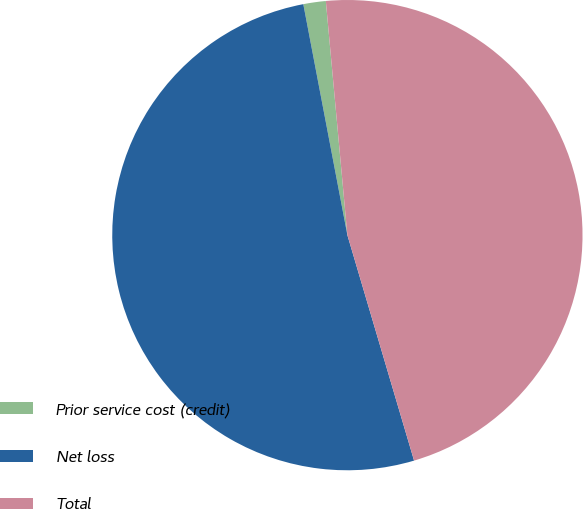Convert chart. <chart><loc_0><loc_0><loc_500><loc_500><pie_chart><fcel>Prior service cost (credit)<fcel>Net loss<fcel>Total<nl><fcel>1.54%<fcel>51.58%<fcel>46.89%<nl></chart> 